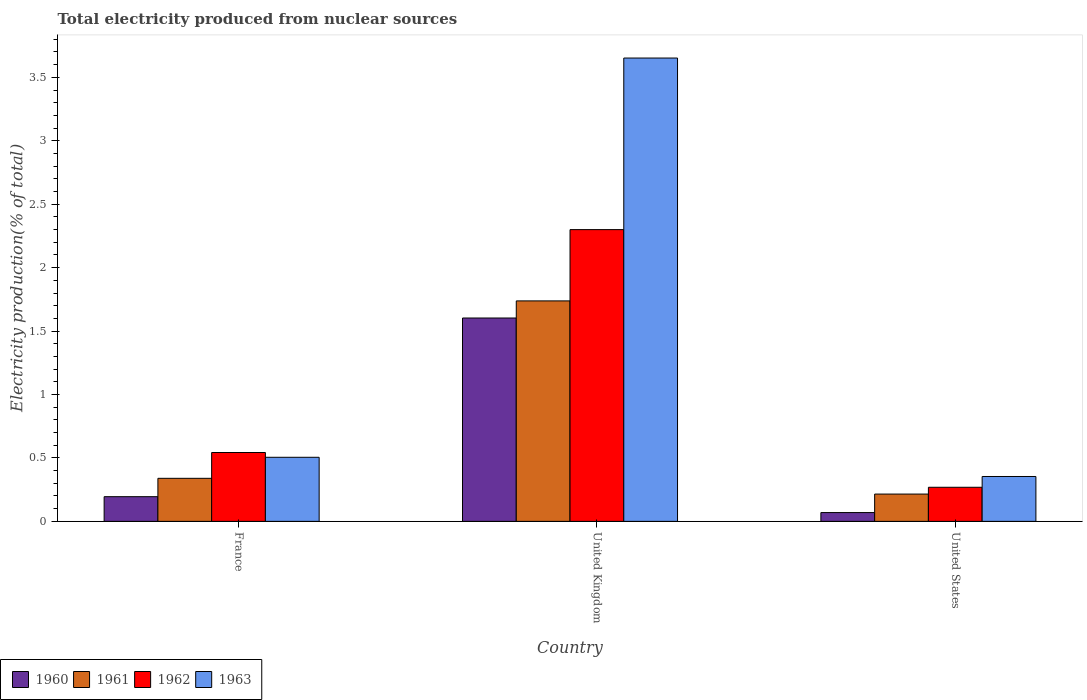How many groups of bars are there?
Ensure brevity in your answer.  3. Are the number of bars per tick equal to the number of legend labels?
Your answer should be compact. Yes. In how many cases, is the number of bars for a given country not equal to the number of legend labels?
Ensure brevity in your answer.  0. What is the total electricity produced in 1962 in United States?
Keep it short and to the point. 0.27. Across all countries, what is the maximum total electricity produced in 1960?
Ensure brevity in your answer.  1.6. Across all countries, what is the minimum total electricity produced in 1963?
Provide a succinct answer. 0.35. In which country was the total electricity produced in 1963 maximum?
Provide a succinct answer. United Kingdom. In which country was the total electricity produced in 1961 minimum?
Offer a terse response. United States. What is the total total electricity produced in 1961 in the graph?
Offer a very short reply. 2.29. What is the difference between the total electricity produced in 1960 in France and that in United Kingdom?
Provide a short and direct response. -1.41. What is the difference between the total electricity produced in 1961 in United States and the total electricity produced in 1963 in United Kingdom?
Make the answer very short. -3.44. What is the average total electricity produced in 1962 per country?
Your answer should be compact. 1.04. What is the difference between the total electricity produced of/in 1961 and total electricity produced of/in 1962 in United Kingdom?
Provide a succinct answer. -0.56. What is the ratio of the total electricity produced in 1960 in France to that in United States?
Offer a very short reply. 2.81. Is the total electricity produced in 1962 in France less than that in United Kingdom?
Make the answer very short. Yes. Is the difference between the total electricity produced in 1961 in France and United States greater than the difference between the total electricity produced in 1962 in France and United States?
Ensure brevity in your answer.  No. What is the difference between the highest and the second highest total electricity produced in 1962?
Provide a succinct answer. 0.27. What is the difference between the highest and the lowest total electricity produced in 1961?
Offer a terse response. 1.52. Is it the case that in every country, the sum of the total electricity produced in 1962 and total electricity produced in 1961 is greater than the sum of total electricity produced in 1960 and total electricity produced in 1963?
Your response must be concise. No. What does the 2nd bar from the right in United Kingdom represents?
Provide a succinct answer. 1962. Is it the case that in every country, the sum of the total electricity produced in 1962 and total electricity produced in 1961 is greater than the total electricity produced in 1960?
Ensure brevity in your answer.  Yes. How many bars are there?
Make the answer very short. 12. Are all the bars in the graph horizontal?
Offer a terse response. No. What is the difference between two consecutive major ticks on the Y-axis?
Your answer should be compact. 0.5. Are the values on the major ticks of Y-axis written in scientific E-notation?
Ensure brevity in your answer.  No. Does the graph contain grids?
Your response must be concise. No. How many legend labels are there?
Provide a short and direct response. 4. What is the title of the graph?
Give a very brief answer. Total electricity produced from nuclear sources. What is the label or title of the X-axis?
Give a very brief answer. Country. What is the Electricity production(% of total) in 1960 in France?
Offer a terse response. 0.19. What is the Electricity production(% of total) of 1961 in France?
Keep it short and to the point. 0.34. What is the Electricity production(% of total) in 1962 in France?
Your answer should be very brief. 0.54. What is the Electricity production(% of total) in 1963 in France?
Give a very brief answer. 0.51. What is the Electricity production(% of total) of 1960 in United Kingdom?
Provide a succinct answer. 1.6. What is the Electricity production(% of total) of 1961 in United Kingdom?
Your answer should be very brief. 1.74. What is the Electricity production(% of total) in 1962 in United Kingdom?
Give a very brief answer. 2.3. What is the Electricity production(% of total) in 1963 in United Kingdom?
Ensure brevity in your answer.  3.65. What is the Electricity production(% of total) in 1960 in United States?
Your answer should be compact. 0.07. What is the Electricity production(% of total) in 1961 in United States?
Make the answer very short. 0.22. What is the Electricity production(% of total) of 1962 in United States?
Your answer should be very brief. 0.27. What is the Electricity production(% of total) of 1963 in United States?
Your answer should be very brief. 0.35. Across all countries, what is the maximum Electricity production(% of total) of 1960?
Provide a short and direct response. 1.6. Across all countries, what is the maximum Electricity production(% of total) of 1961?
Provide a succinct answer. 1.74. Across all countries, what is the maximum Electricity production(% of total) of 1962?
Your answer should be very brief. 2.3. Across all countries, what is the maximum Electricity production(% of total) of 1963?
Make the answer very short. 3.65. Across all countries, what is the minimum Electricity production(% of total) of 1960?
Provide a succinct answer. 0.07. Across all countries, what is the minimum Electricity production(% of total) of 1961?
Provide a short and direct response. 0.22. Across all countries, what is the minimum Electricity production(% of total) of 1962?
Your answer should be compact. 0.27. Across all countries, what is the minimum Electricity production(% of total) in 1963?
Give a very brief answer. 0.35. What is the total Electricity production(% of total) of 1960 in the graph?
Your answer should be compact. 1.87. What is the total Electricity production(% of total) in 1961 in the graph?
Offer a very short reply. 2.29. What is the total Electricity production(% of total) of 1962 in the graph?
Offer a very short reply. 3.11. What is the total Electricity production(% of total) of 1963 in the graph?
Your answer should be very brief. 4.51. What is the difference between the Electricity production(% of total) of 1960 in France and that in United Kingdom?
Your answer should be compact. -1.41. What is the difference between the Electricity production(% of total) in 1961 in France and that in United Kingdom?
Ensure brevity in your answer.  -1.4. What is the difference between the Electricity production(% of total) of 1962 in France and that in United Kingdom?
Ensure brevity in your answer.  -1.76. What is the difference between the Electricity production(% of total) in 1963 in France and that in United Kingdom?
Offer a terse response. -3.15. What is the difference between the Electricity production(% of total) of 1960 in France and that in United States?
Make the answer very short. 0.13. What is the difference between the Electricity production(% of total) of 1961 in France and that in United States?
Provide a short and direct response. 0.12. What is the difference between the Electricity production(% of total) of 1962 in France and that in United States?
Ensure brevity in your answer.  0.27. What is the difference between the Electricity production(% of total) in 1963 in France and that in United States?
Provide a short and direct response. 0.15. What is the difference between the Electricity production(% of total) of 1960 in United Kingdom and that in United States?
Offer a terse response. 1.53. What is the difference between the Electricity production(% of total) in 1961 in United Kingdom and that in United States?
Make the answer very short. 1.52. What is the difference between the Electricity production(% of total) in 1962 in United Kingdom and that in United States?
Provide a short and direct response. 2.03. What is the difference between the Electricity production(% of total) in 1963 in United Kingdom and that in United States?
Give a very brief answer. 3.3. What is the difference between the Electricity production(% of total) of 1960 in France and the Electricity production(% of total) of 1961 in United Kingdom?
Your answer should be very brief. -1.54. What is the difference between the Electricity production(% of total) in 1960 in France and the Electricity production(% of total) in 1962 in United Kingdom?
Offer a terse response. -2.11. What is the difference between the Electricity production(% of total) in 1960 in France and the Electricity production(% of total) in 1963 in United Kingdom?
Offer a terse response. -3.46. What is the difference between the Electricity production(% of total) in 1961 in France and the Electricity production(% of total) in 1962 in United Kingdom?
Give a very brief answer. -1.96. What is the difference between the Electricity production(% of total) in 1961 in France and the Electricity production(% of total) in 1963 in United Kingdom?
Make the answer very short. -3.31. What is the difference between the Electricity production(% of total) of 1962 in France and the Electricity production(% of total) of 1963 in United Kingdom?
Keep it short and to the point. -3.11. What is the difference between the Electricity production(% of total) of 1960 in France and the Electricity production(% of total) of 1961 in United States?
Provide a succinct answer. -0.02. What is the difference between the Electricity production(% of total) of 1960 in France and the Electricity production(% of total) of 1962 in United States?
Keep it short and to the point. -0.07. What is the difference between the Electricity production(% of total) in 1960 in France and the Electricity production(% of total) in 1963 in United States?
Provide a short and direct response. -0.16. What is the difference between the Electricity production(% of total) of 1961 in France and the Electricity production(% of total) of 1962 in United States?
Offer a very short reply. 0.07. What is the difference between the Electricity production(% of total) in 1961 in France and the Electricity production(% of total) in 1963 in United States?
Give a very brief answer. -0.01. What is the difference between the Electricity production(% of total) of 1962 in France and the Electricity production(% of total) of 1963 in United States?
Your response must be concise. 0.19. What is the difference between the Electricity production(% of total) in 1960 in United Kingdom and the Electricity production(% of total) in 1961 in United States?
Provide a short and direct response. 1.39. What is the difference between the Electricity production(% of total) in 1960 in United Kingdom and the Electricity production(% of total) in 1962 in United States?
Your response must be concise. 1.33. What is the difference between the Electricity production(% of total) in 1960 in United Kingdom and the Electricity production(% of total) in 1963 in United States?
Provide a succinct answer. 1.25. What is the difference between the Electricity production(% of total) in 1961 in United Kingdom and the Electricity production(% of total) in 1962 in United States?
Your response must be concise. 1.47. What is the difference between the Electricity production(% of total) in 1961 in United Kingdom and the Electricity production(% of total) in 1963 in United States?
Keep it short and to the point. 1.38. What is the difference between the Electricity production(% of total) in 1962 in United Kingdom and the Electricity production(% of total) in 1963 in United States?
Make the answer very short. 1.95. What is the average Electricity production(% of total) of 1960 per country?
Offer a very short reply. 0.62. What is the average Electricity production(% of total) in 1961 per country?
Offer a very short reply. 0.76. What is the average Electricity production(% of total) in 1963 per country?
Provide a succinct answer. 1.5. What is the difference between the Electricity production(% of total) of 1960 and Electricity production(% of total) of 1961 in France?
Provide a short and direct response. -0.14. What is the difference between the Electricity production(% of total) in 1960 and Electricity production(% of total) in 1962 in France?
Provide a succinct answer. -0.35. What is the difference between the Electricity production(% of total) in 1960 and Electricity production(% of total) in 1963 in France?
Offer a very short reply. -0.31. What is the difference between the Electricity production(% of total) of 1961 and Electricity production(% of total) of 1962 in France?
Your answer should be compact. -0.2. What is the difference between the Electricity production(% of total) in 1961 and Electricity production(% of total) in 1963 in France?
Your answer should be compact. -0.17. What is the difference between the Electricity production(% of total) in 1962 and Electricity production(% of total) in 1963 in France?
Make the answer very short. 0.04. What is the difference between the Electricity production(% of total) in 1960 and Electricity production(% of total) in 1961 in United Kingdom?
Provide a short and direct response. -0.13. What is the difference between the Electricity production(% of total) of 1960 and Electricity production(% of total) of 1962 in United Kingdom?
Your answer should be very brief. -0.7. What is the difference between the Electricity production(% of total) of 1960 and Electricity production(% of total) of 1963 in United Kingdom?
Ensure brevity in your answer.  -2.05. What is the difference between the Electricity production(% of total) of 1961 and Electricity production(% of total) of 1962 in United Kingdom?
Your response must be concise. -0.56. What is the difference between the Electricity production(% of total) of 1961 and Electricity production(% of total) of 1963 in United Kingdom?
Provide a succinct answer. -1.91. What is the difference between the Electricity production(% of total) in 1962 and Electricity production(% of total) in 1963 in United Kingdom?
Ensure brevity in your answer.  -1.35. What is the difference between the Electricity production(% of total) in 1960 and Electricity production(% of total) in 1961 in United States?
Provide a short and direct response. -0.15. What is the difference between the Electricity production(% of total) in 1960 and Electricity production(% of total) in 1962 in United States?
Keep it short and to the point. -0.2. What is the difference between the Electricity production(% of total) of 1960 and Electricity production(% of total) of 1963 in United States?
Provide a short and direct response. -0.28. What is the difference between the Electricity production(% of total) in 1961 and Electricity production(% of total) in 1962 in United States?
Offer a terse response. -0.05. What is the difference between the Electricity production(% of total) of 1961 and Electricity production(% of total) of 1963 in United States?
Provide a short and direct response. -0.14. What is the difference between the Electricity production(% of total) in 1962 and Electricity production(% of total) in 1963 in United States?
Your response must be concise. -0.09. What is the ratio of the Electricity production(% of total) in 1960 in France to that in United Kingdom?
Ensure brevity in your answer.  0.12. What is the ratio of the Electricity production(% of total) in 1961 in France to that in United Kingdom?
Your response must be concise. 0.2. What is the ratio of the Electricity production(% of total) in 1962 in France to that in United Kingdom?
Give a very brief answer. 0.24. What is the ratio of the Electricity production(% of total) of 1963 in France to that in United Kingdom?
Offer a very short reply. 0.14. What is the ratio of the Electricity production(% of total) in 1960 in France to that in United States?
Ensure brevity in your answer.  2.81. What is the ratio of the Electricity production(% of total) in 1961 in France to that in United States?
Ensure brevity in your answer.  1.58. What is the ratio of the Electricity production(% of total) of 1962 in France to that in United States?
Offer a very short reply. 2.02. What is the ratio of the Electricity production(% of total) in 1963 in France to that in United States?
Your response must be concise. 1.43. What is the ratio of the Electricity production(% of total) of 1960 in United Kingdom to that in United States?
Give a very brief answer. 23.14. What is the ratio of the Electricity production(% of total) of 1961 in United Kingdom to that in United States?
Keep it short and to the point. 8.08. What is the ratio of the Electricity production(% of total) in 1962 in United Kingdom to that in United States?
Your response must be concise. 8.56. What is the ratio of the Electricity production(% of total) in 1963 in United Kingdom to that in United States?
Make the answer very short. 10.32. What is the difference between the highest and the second highest Electricity production(% of total) in 1960?
Offer a terse response. 1.41. What is the difference between the highest and the second highest Electricity production(% of total) of 1961?
Provide a succinct answer. 1.4. What is the difference between the highest and the second highest Electricity production(% of total) in 1962?
Provide a succinct answer. 1.76. What is the difference between the highest and the second highest Electricity production(% of total) of 1963?
Give a very brief answer. 3.15. What is the difference between the highest and the lowest Electricity production(% of total) of 1960?
Offer a terse response. 1.53. What is the difference between the highest and the lowest Electricity production(% of total) of 1961?
Make the answer very short. 1.52. What is the difference between the highest and the lowest Electricity production(% of total) of 1962?
Offer a very short reply. 2.03. What is the difference between the highest and the lowest Electricity production(% of total) of 1963?
Your answer should be compact. 3.3. 